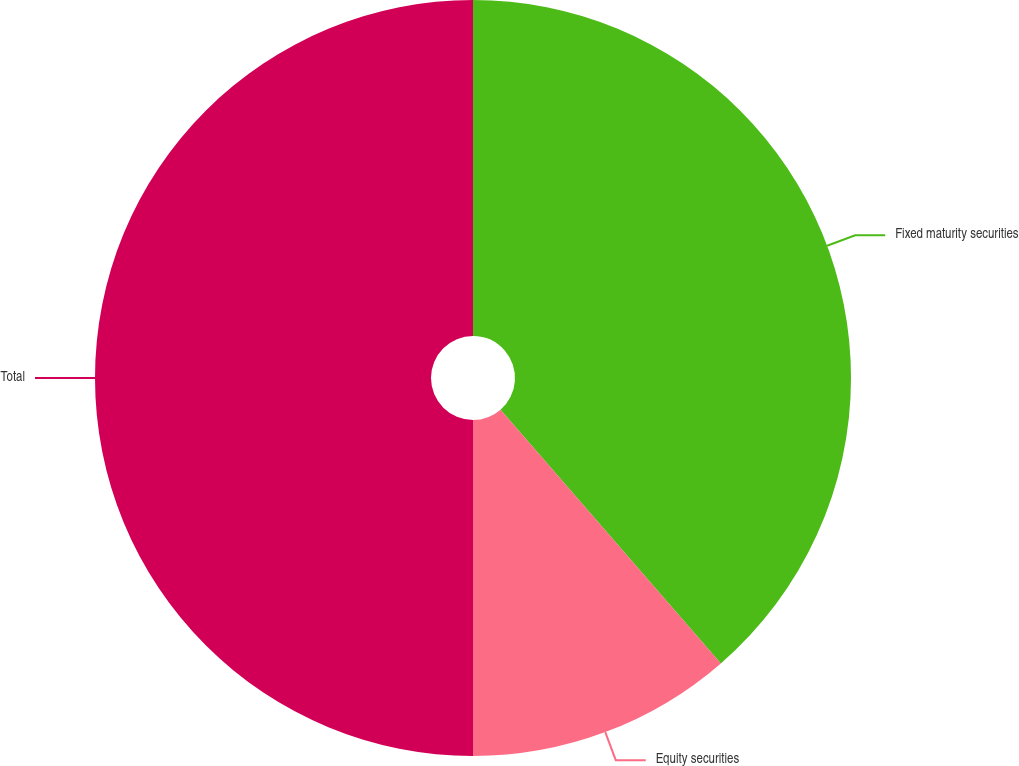<chart> <loc_0><loc_0><loc_500><loc_500><pie_chart><fcel>Fixed maturity securities<fcel>Equity securities<fcel>Total<nl><fcel>38.62%<fcel>11.38%<fcel>50.0%<nl></chart> 